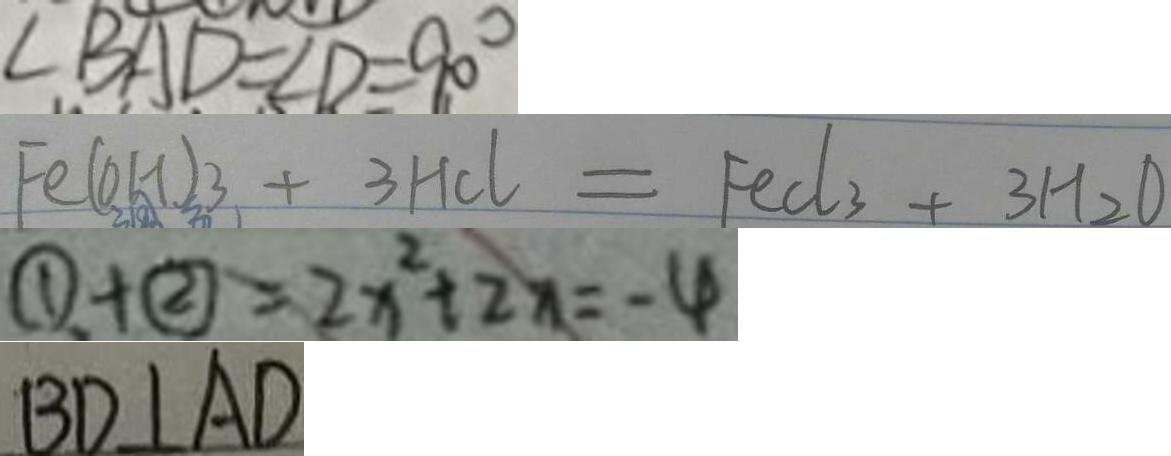<formula> <loc_0><loc_0><loc_500><loc_500>\angle B A D = \angle D = 9 0 ^ { \circ } 
 F e ( O H ) 3 + 3 H C l = F e C l _ { 3 } + 3 H _ { 2 } O 
 \textcircled { 1 } + \textcircled { 2 } = 2 x ^ { 2 } + 2 x = - 4 
 B D \bot A D</formula> 